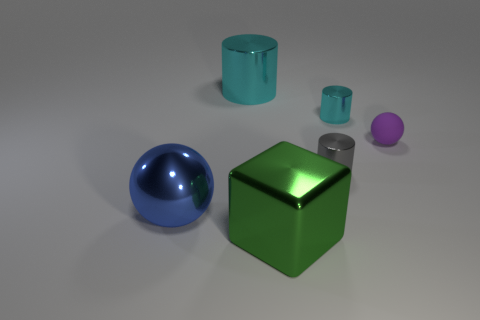How many tiny metallic objects are left of the cyan metal cylinder that is right of the large green shiny block?
Your answer should be very brief. 1. Is there anything else that is made of the same material as the small purple object?
Provide a succinct answer. No. How many things are tiny metal things that are in front of the tiny purple object or blue things?
Provide a short and direct response. 2. There is a ball that is to the right of the large blue shiny ball; how big is it?
Give a very brief answer. Small. What is the material of the purple ball?
Your answer should be compact. Rubber. What is the shape of the cyan metallic thing left of the big shiny object that is to the right of the large cyan metallic cylinder?
Provide a short and direct response. Cylinder. What number of other objects are there of the same shape as the purple thing?
Your response must be concise. 1. There is a big cyan metallic cylinder; are there any large green metal blocks in front of it?
Your response must be concise. Yes. The matte sphere is what color?
Provide a succinct answer. Purple. Do the large metallic cylinder and the tiny shiny cylinder that is behind the tiny rubber thing have the same color?
Offer a very short reply. Yes. 